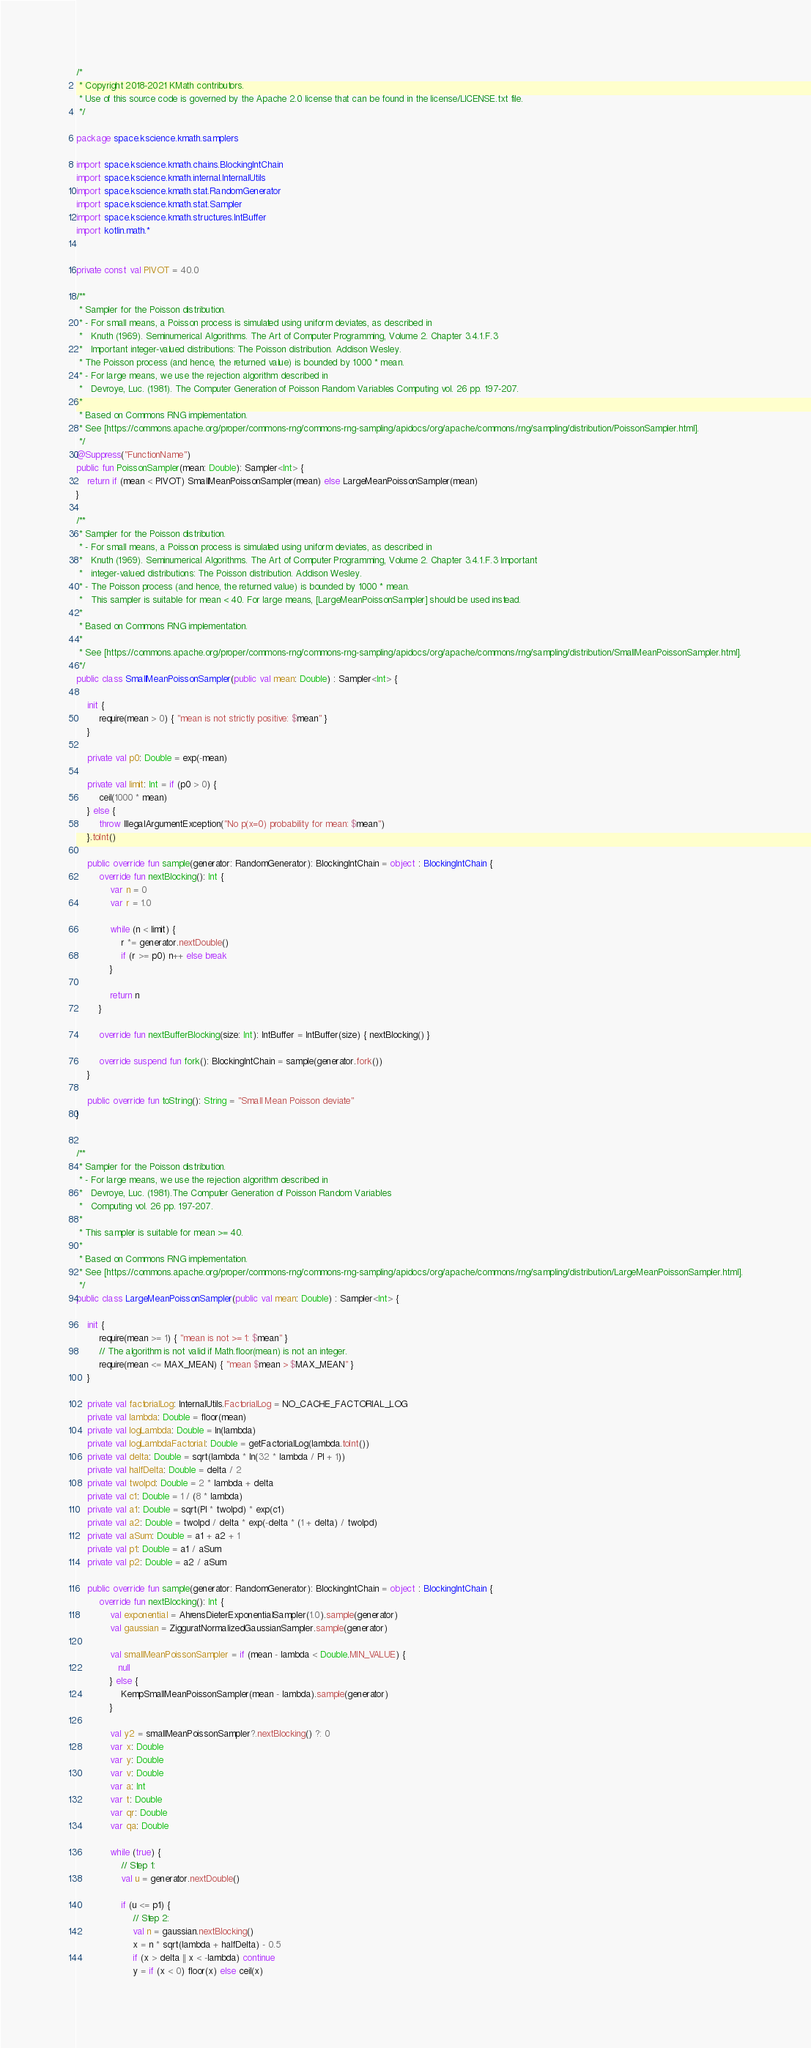Convert code to text. <code><loc_0><loc_0><loc_500><loc_500><_Kotlin_>/*
 * Copyright 2018-2021 KMath contributors.
 * Use of this source code is governed by the Apache 2.0 license that can be found in the license/LICENSE.txt file.
 */

package space.kscience.kmath.samplers

import space.kscience.kmath.chains.BlockingIntChain
import space.kscience.kmath.internal.InternalUtils
import space.kscience.kmath.stat.RandomGenerator
import space.kscience.kmath.stat.Sampler
import space.kscience.kmath.structures.IntBuffer
import kotlin.math.*


private const val PIVOT = 40.0

/**
 * Sampler for the Poisson distribution.
 * - For small means, a Poisson process is simulated using uniform deviates, as described in
 *   Knuth (1969). Seminumerical Algorithms. The Art of Computer Programming, Volume 2. Chapter 3.4.1.F.3
 *   Important integer-valued distributions: The Poisson distribution. Addison Wesley.
 * The Poisson process (and hence, the returned value) is bounded by 1000 * mean.
 * - For large means, we use the rejection algorithm described in
 *   Devroye, Luc. (1981). The Computer Generation of Poisson Random Variables Computing vol. 26 pp. 197-207.
 *
 * Based on Commons RNG implementation.
 * See [https://commons.apache.org/proper/commons-rng/commons-rng-sampling/apidocs/org/apache/commons/rng/sampling/distribution/PoissonSampler.html].
 */
@Suppress("FunctionName")
public fun PoissonSampler(mean: Double): Sampler<Int> {
    return if (mean < PIVOT) SmallMeanPoissonSampler(mean) else LargeMeanPoissonSampler(mean)
}

/**
 * Sampler for the Poisson distribution.
 * - For small means, a Poisson process is simulated using uniform deviates, as described in
 *   Knuth (1969). Seminumerical Algorithms. The Art of Computer Programming, Volume 2. Chapter 3.4.1.F.3 Important
 *   integer-valued distributions: The Poisson distribution. Addison Wesley.
 * - The Poisson process (and hence, the returned value) is bounded by 1000 * mean.
 *   This sampler is suitable for mean < 40. For large means, [LargeMeanPoissonSampler] should be used instead.
 *
 * Based on Commons RNG implementation.
 *
 * See [https://commons.apache.org/proper/commons-rng/commons-rng-sampling/apidocs/org/apache/commons/rng/sampling/distribution/SmallMeanPoissonSampler.html].
 */
public class SmallMeanPoissonSampler(public val mean: Double) : Sampler<Int> {

    init {
        require(mean > 0) { "mean is not strictly positive: $mean" }
    }

    private val p0: Double = exp(-mean)

    private val limit: Int = if (p0 > 0) {
        ceil(1000 * mean)
    } else {
        throw IllegalArgumentException("No p(x=0) probability for mean: $mean")
    }.toInt()

    public override fun sample(generator: RandomGenerator): BlockingIntChain = object : BlockingIntChain {
        override fun nextBlocking(): Int {
            var n = 0
            var r = 1.0

            while (n < limit) {
                r *= generator.nextDouble()
                if (r >= p0) n++ else break
            }

            return n
        }

        override fun nextBufferBlocking(size: Int): IntBuffer = IntBuffer(size) { nextBlocking() }

        override suspend fun fork(): BlockingIntChain = sample(generator.fork())
    }

    public override fun toString(): String = "Small Mean Poisson deviate"
}


/**
 * Sampler for the Poisson distribution.
 * - For large means, we use the rejection algorithm described in
 *   Devroye, Luc. (1981).The Computer Generation of Poisson Random Variables
 *   Computing vol. 26 pp. 197-207.
 *
 * This sampler is suitable for mean >= 40.
 *
 * Based on Commons RNG implementation.
 * See [https://commons.apache.org/proper/commons-rng/commons-rng-sampling/apidocs/org/apache/commons/rng/sampling/distribution/LargeMeanPoissonSampler.html].
 */
public class LargeMeanPoissonSampler(public val mean: Double) : Sampler<Int> {

    init {
        require(mean >= 1) { "mean is not >= 1: $mean" }
        // The algorithm is not valid if Math.floor(mean) is not an integer.
        require(mean <= MAX_MEAN) { "mean $mean > $MAX_MEAN" }
    }

    private val factorialLog: InternalUtils.FactorialLog = NO_CACHE_FACTORIAL_LOG
    private val lambda: Double = floor(mean)
    private val logLambda: Double = ln(lambda)
    private val logLambdaFactorial: Double = getFactorialLog(lambda.toInt())
    private val delta: Double = sqrt(lambda * ln(32 * lambda / PI + 1))
    private val halfDelta: Double = delta / 2
    private val twolpd: Double = 2 * lambda + delta
    private val c1: Double = 1 / (8 * lambda)
    private val a1: Double = sqrt(PI * twolpd) * exp(c1)
    private val a2: Double = twolpd / delta * exp(-delta * (1 + delta) / twolpd)
    private val aSum: Double = a1 + a2 + 1
    private val p1: Double = a1 / aSum
    private val p2: Double = a2 / aSum

    public override fun sample(generator: RandomGenerator): BlockingIntChain = object : BlockingIntChain {
        override fun nextBlocking(): Int {
            val exponential = AhrensDieterExponentialSampler(1.0).sample(generator)
            val gaussian = ZigguratNormalizedGaussianSampler.sample(generator)

            val smallMeanPoissonSampler = if (mean - lambda < Double.MIN_VALUE) {
               null
            } else {
                KempSmallMeanPoissonSampler(mean - lambda).sample(generator)
            }

            val y2 = smallMeanPoissonSampler?.nextBlocking() ?: 0
            var x: Double
            var y: Double
            var v: Double
            var a: Int
            var t: Double
            var qr: Double
            var qa: Double

            while (true) {
                // Step 1:
                val u = generator.nextDouble()

                if (u <= p1) {
                    // Step 2:
                    val n = gaussian.nextBlocking()
                    x = n * sqrt(lambda + halfDelta) - 0.5
                    if (x > delta || x < -lambda) continue
                    y = if (x < 0) floor(x) else ceil(x)</code> 